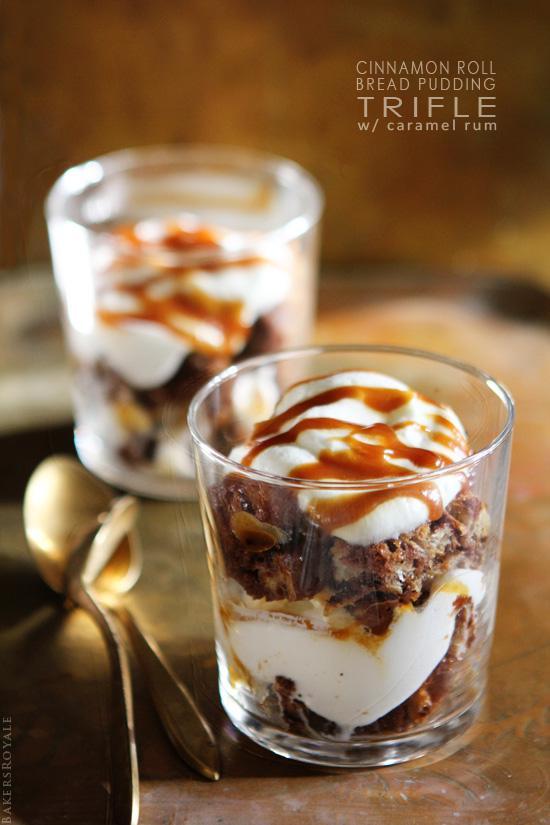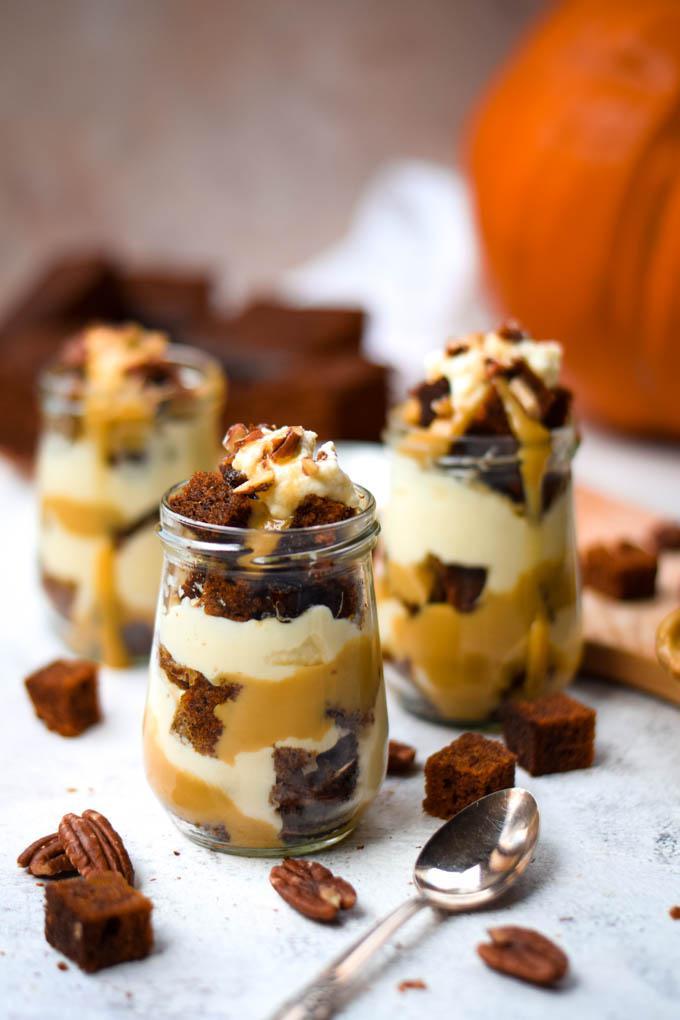The first image is the image on the left, the second image is the image on the right. Analyze the images presented: Is the assertion "The left image shows one layered dessert served in a footed glass." valid? Answer yes or no. No. The first image is the image on the left, the second image is the image on the right. For the images displayed, is the sentence "One large fancy dessert and three servings of a different dessert are shown." factually correct? Answer yes or no. No. 